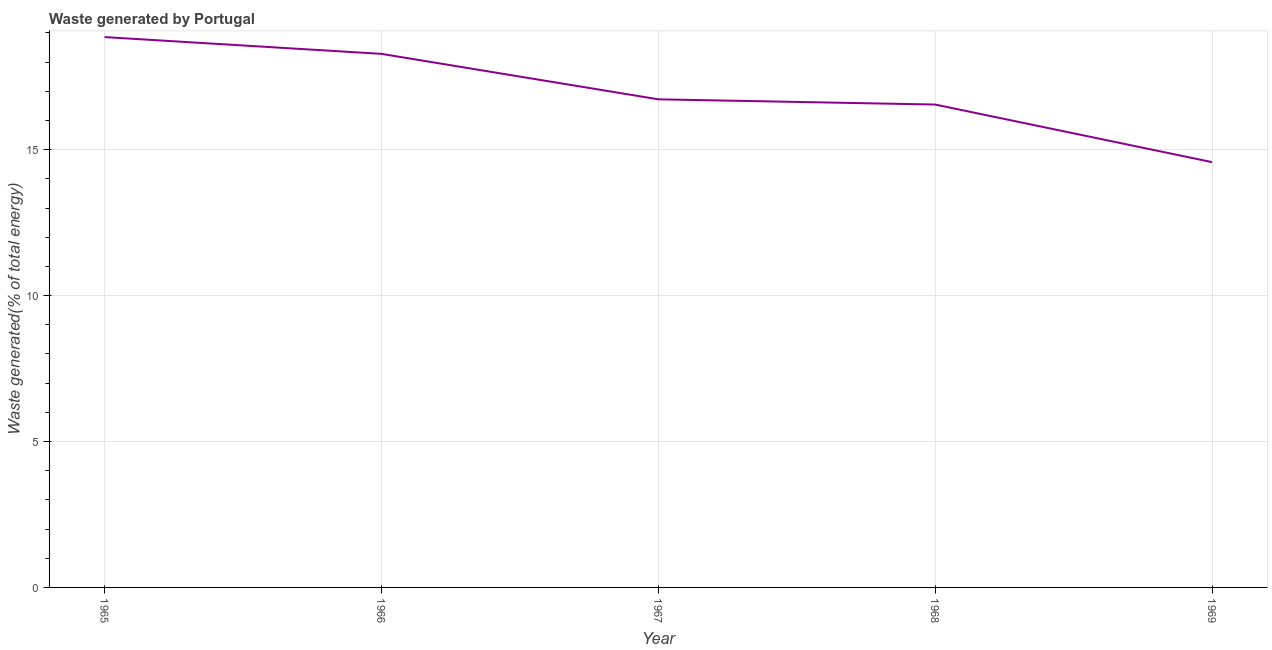What is the amount of waste generated in 1967?
Provide a short and direct response. 16.73. Across all years, what is the maximum amount of waste generated?
Make the answer very short. 18.86. Across all years, what is the minimum amount of waste generated?
Offer a very short reply. 14.57. In which year was the amount of waste generated maximum?
Your response must be concise. 1965. In which year was the amount of waste generated minimum?
Offer a terse response. 1969. What is the sum of the amount of waste generated?
Keep it short and to the point. 84.99. What is the difference between the amount of waste generated in 1968 and 1969?
Provide a short and direct response. 1.97. What is the average amount of waste generated per year?
Give a very brief answer. 17. What is the median amount of waste generated?
Your response must be concise. 16.73. What is the ratio of the amount of waste generated in 1966 to that in 1969?
Provide a short and direct response. 1.25. Is the amount of waste generated in 1967 less than that in 1969?
Your answer should be very brief. No. Is the difference between the amount of waste generated in 1966 and 1967 greater than the difference between any two years?
Provide a short and direct response. No. What is the difference between the highest and the second highest amount of waste generated?
Your answer should be very brief. 0.57. Is the sum of the amount of waste generated in 1967 and 1968 greater than the maximum amount of waste generated across all years?
Make the answer very short. Yes. What is the difference between the highest and the lowest amount of waste generated?
Your answer should be compact. 4.29. In how many years, is the amount of waste generated greater than the average amount of waste generated taken over all years?
Your answer should be compact. 2. Does the amount of waste generated monotonically increase over the years?
Keep it short and to the point. No. How many lines are there?
Give a very brief answer. 1. Does the graph contain any zero values?
Keep it short and to the point. No. What is the title of the graph?
Keep it short and to the point. Waste generated by Portugal. What is the label or title of the Y-axis?
Give a very brief answer. Waste generated(% of total energy). What is the Waste generated(% of total energy) in 1965?
Ensure brevity in your answer.  18.86. What is the Waste generated(% of total energy) in 1966?
Keep it short and to the point. 18.28. What is the Waste generated(% of total energy) of 1967?
Your response must be concise. 16.73. What is the Waste generated(% of total energy) of 1968?
Provide a succinct answer. 16.55. What is the Waste generated(% of total energy) in 1969?
Ensure brevity in your answer.  14.57. What is the difference between the Waste generated(% of total energy) in 1965 and 1966?
Your response must be concise. 0.57. What is the difference between the Waste generated(% of total energy) in 1965 and 1967?
Keep it short and to the point. 2.13. What is the difference between the Waste generated(% of total energy) in 1965 and 1968?
Make the answer very short. 2.31. What is the difference between the Waste generated(% of total energy) in 1965 and 1969?
Your response must be concise. 4.29. What is the difference between the Waste generated(% of total energy) in 1966 and 1967?
Keep it short and to the point. 1.56. What is the difference between the Waste generated(% of total energy) in 1966 and 1968?
Give a very brief answer. 1.74. What is the difference between the Waste generated(% of total energy) in 1966 and 1969?
Provide a short and direct response. 3.71. What is the difference between the Waste generated(% of total energy) in 1967 and 1968?
Provide a succinct answer. 0.18. What is the difference between the Waste generated(% of total energy) in 1967 and 1969?
Your answer should be very brief. 2.15. What is the difference between the Waste generated(% of total energy) in 1968 and 1969?
Make the answer very short. 1.97. What is the ratio of the Waste generated(% of total energy) in 1965 to that in 1966?
Your response must be concise. 1.03. What is the ratio of the Waste generated(% of total energy) in 1965 to that in 1967?
Your response must be concise. 1.13. What is the ratio of the Waste generated(% of total energy) in 1965 to that in 1968?
Keep it short and to the point. 1.14. What is the ratio of the Waste generated(% of total energy) in 1965 to that in 1969?
Keep it short and to the point. 1.29. What is the ratio of the Waste generated(% of total energy) in 1966 to that in 1967?
Your answer should be compact. 1.09. What is the ratio of the Waste generated(% of total energy) in 1966 to that in 1968?
Your answer should be compact. 1.1. What is the ratio of the Waste generated(% of total energy) in 1966 to that in 1969?
Offer a terse response. 1.25. What is the ratio of the Waste generated(% of total energy) in 1967 to that in 1969?
Ensure brevity in your answer.  1.15. What is the ratio of the Waste generated(% of total energy) in 1968 to that in 1969?
Your response must be concise. 1.14. 